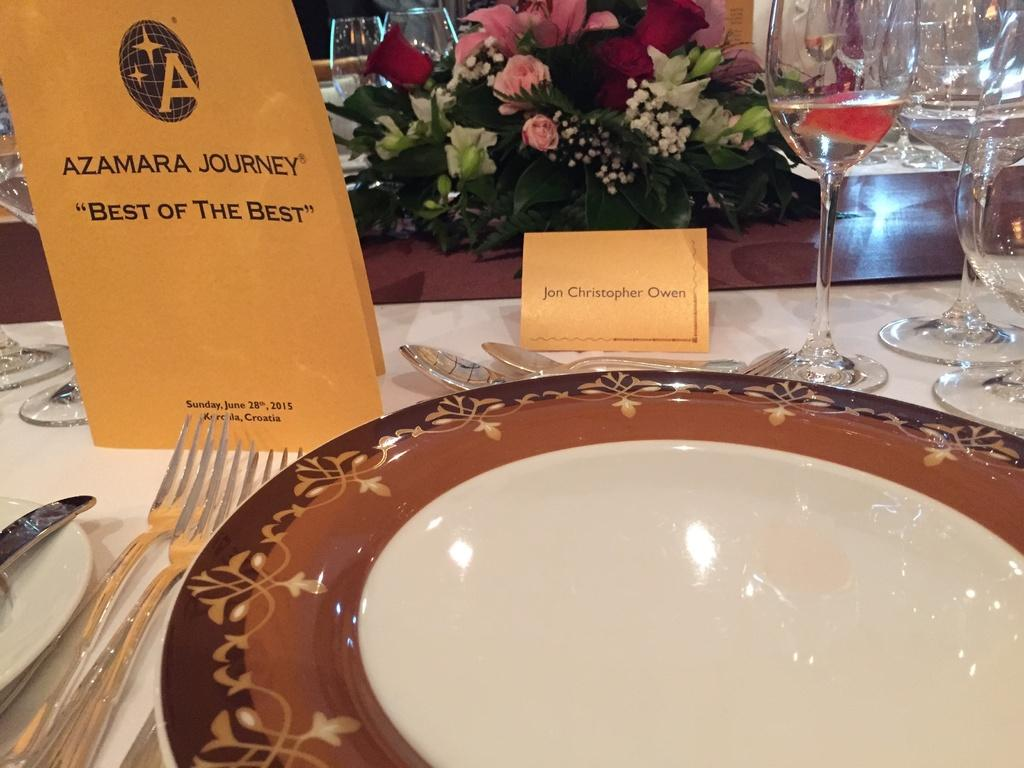What piece of furniture is present in the image? There is a table in the image. What items are placed on the table? There are plates, forks, spoons, knives, cards, drinking glasses, and a flower vase on the table. How many types of utensils are on the table? There are three types of utensils on the table: forks, spoons, and knives. What type of behavior can be observed from the chin in the image? There is no chin present in the image, so it is not possible to observe any behavior from it. 